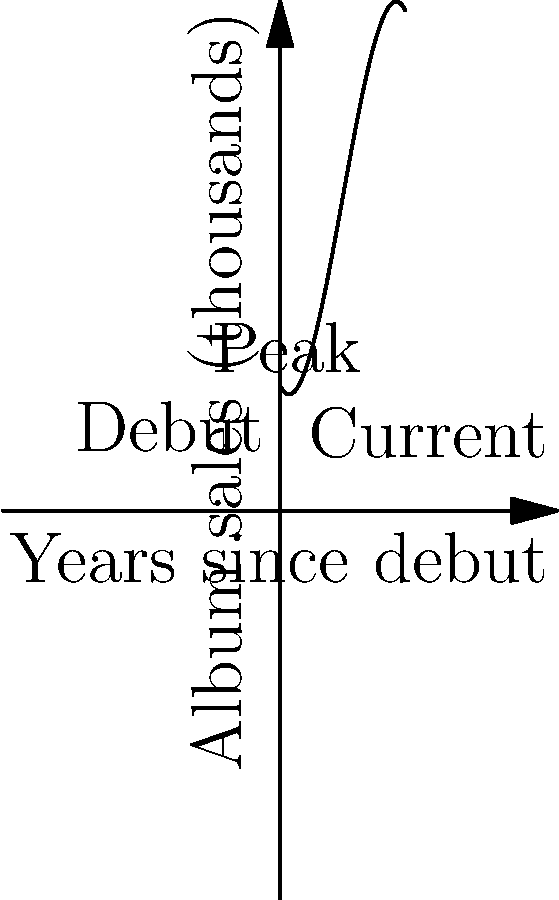The graph represents Peter Lemongello's album sales (in thousands) over the years since his debut. The function modeling his sales is given by $f(x) = -0.1x^3 + 1.5x^2 - 2x + 10$, where $x$ represents the number of years since his debut. At which year did Peter's album sales reach their peak? To find the peak of Peter Lemongello's album sales, we need to follow these steps:

1) The peak occurs at the maximum point of the function, which is where the derivative equals zero.

2) Let's find the derivative of $f(x)$:
   $f'(x) = -0.3x^2 + 3x - 2$

3) Set the derivative to zero and solve:
   $-0.3x^2 + 3x - 2 = 0$

4) This is a quadratic equation. We can solve it using the quadratic formula:
   $x = \frac{-b \pm \sqrt{b^2 - 4ac}}{2a}$

   Where $a = -0.3$, $b = 3$, and $c = -2$

5) Plugging in these values:
   $x = \frac{-3 \pm \sqrt{3^2 - 4(-0.3)(-2)}}{2(-0.3)}$
   $= \frac{-3 \pm \sqrt{9 - 2.4}}{-0.6}$
   $= \frac{-3 \pm \sqrt{6.6}}{-0.6}$

6) This gives us two solutions:
   $x_1 \approx 5$ and $x_2 \approx 1.67$

7) Since we're looking for the maximum (peak), we choose the larger value, $x \approx 5$.

Therefore, Peter Lemongello's album sales peaked approximately 5 years after his debut.
Answer: 5 years after debut 